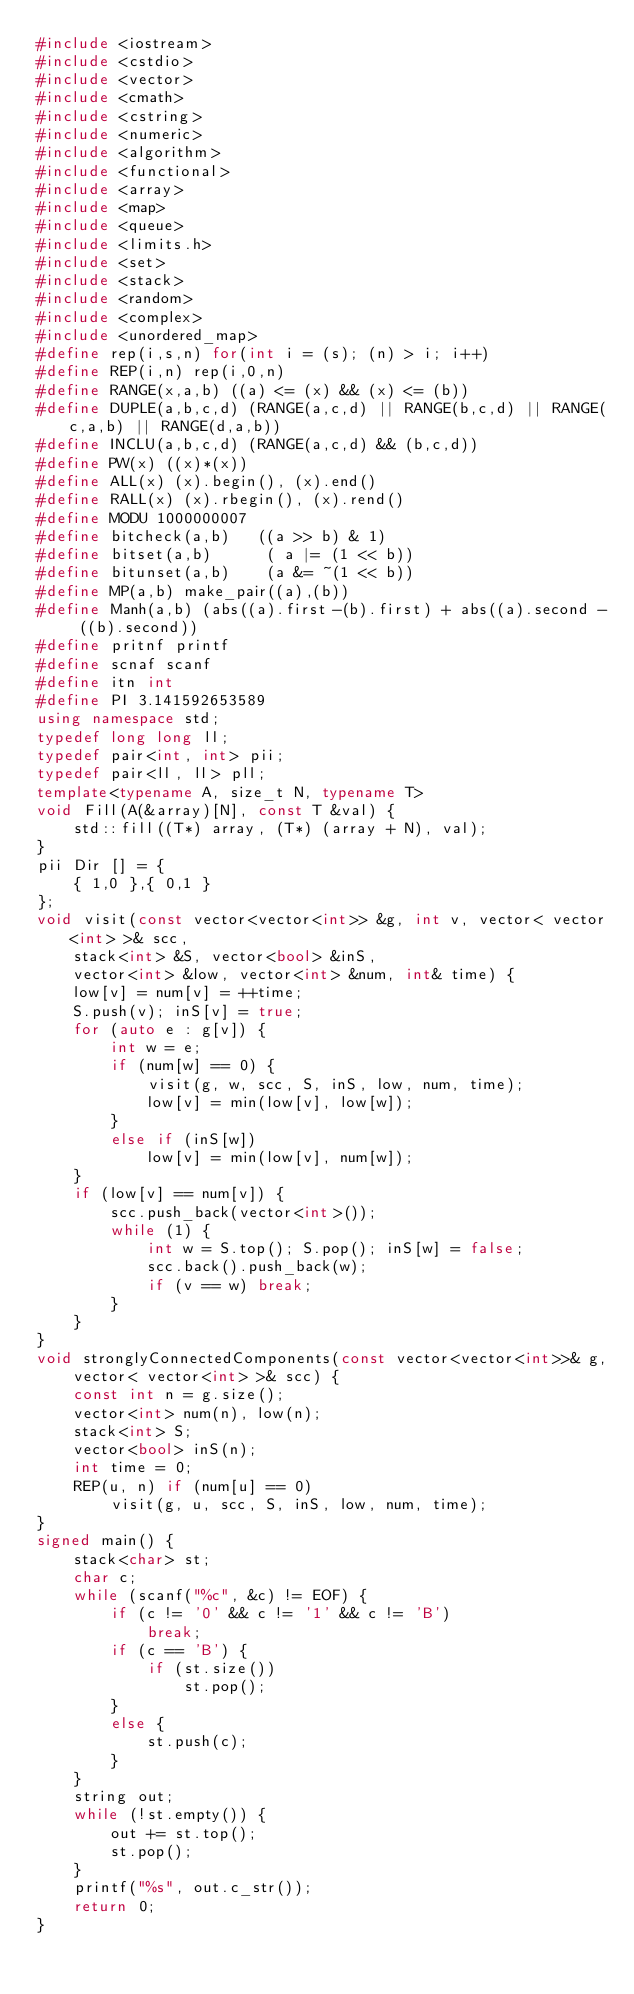Convert code to text. <code><loc_0><loc_0><loc_500><loc_500><_C++_>#include <iostream>
#include <cstdio>
#include <vector>
#include <cmath>
#include <cstring>
#include <numeric>
#include <algorithm>
#include <functional>
#include <array>
#include <map>
#include <queue>
#include <limits.h>
#include <set>
#include <stack>
#include <random>
#include <complex>
#include <unordered_map>
#define rep(i,s,n) for(int i = (s); (n) > i; i++)
#define REP(i,n) rep(i,0,n)
#define RANGE(x,a,b) ((a) <= (x) && (x) <= (b))
#define DUPLE(a,b,c,d) (RANGE(a,c,d) || RANGE(b,c,d) || RANGE(c,a,b) || RANGE(d,a,b))
#define INCLU(a,b,c,d) (RANGE(a,c,d) && (b,c,d))
#define PW(x) ((x)*(x))
#define ALL(x) (x).begin(), (x).end()
#define RALL(x) (x).rbegin(), (x).rend()
#define MODU 1000000007
#define bitcheck(a,b)   ((a >> b) & 1)
#define bitset(a,b)      ( a |= (1 << b))
#define bitunset(a,b)    (a &= ~(1 << b))
#define MP(a,b) make_pair((a),(b))
#define Manh(a,b) (abs((a).first-(b).first) + abs((a).second - ((b).second))
#define pritnf printf
#define scnaf scanf
#define itn int
#define PI 3.141592653589
using namespace std;
typedef long long ll;
typedef pair<int, int> pii;
typedef pair<ll, ll> pll;
template<typename A, size_t N, typename T>
void Fill(A(&array)[N], const T &val) {
	std::fill((T*) array, (T*) (array + N), val);
}
pii Dir [] = {
	{ 1,0 },{ 0,1 }
};
void visit(const vector<vector<int>> &g, int v, vector< vector<int> >& scc,
	stack<int> &S, vector<bool> &inS,
	vector<int> &low, vector<int> &num, int& time) {
	low[v] = num[v] = ++time;
	S.push(v); inS[v] = true;
	for (auto e : g[v]) {
		int w = e;
		if (num[w] == 0) {
			visit(g, w, scc, S, inS, low, num, time);
			low[v] = min(low[v], low[w]);
		}
		else if (inS[w])
			low[v] = min(low[v], num[w]);
	}
	if (low[v] == num[v]) {
		scc.push_back(vector<int>());
		while (1) {
			int w = S.top(); S.pop(); inS[w] = false;
			scc.back().push_back(w);
			if (v == w) break;
		}
	}
}
void stronglyConnectedComponents(const vector<vector<int>>& g,
	vector< vector<int> >& scc) {
	const int n = g.size();
	vector<int> num(n), low(n);
	stack<int> S;
	vector<bool> inS(n);
	int time = 0;
	REP(u, n) if (num[u] == 0)
		visit(g, u, scc, S, inS, low, num, time);
}
signed main() {
	stack<char> st;
	char c;
	while (scanf("%c", &c) != EOF) {
		if (c != '0' && c != '1' && c != 'B')
			break;
		if (c == 'B') {
			if (st.size())
				st.pop();
		}
		else {
			st.push(c);
		}
	}
	string out;
	while (!st.empty()) {
		out += st.top();
		st.pop();
	}
	printf("%s", out.c_str());
	return 0;
}</code> 